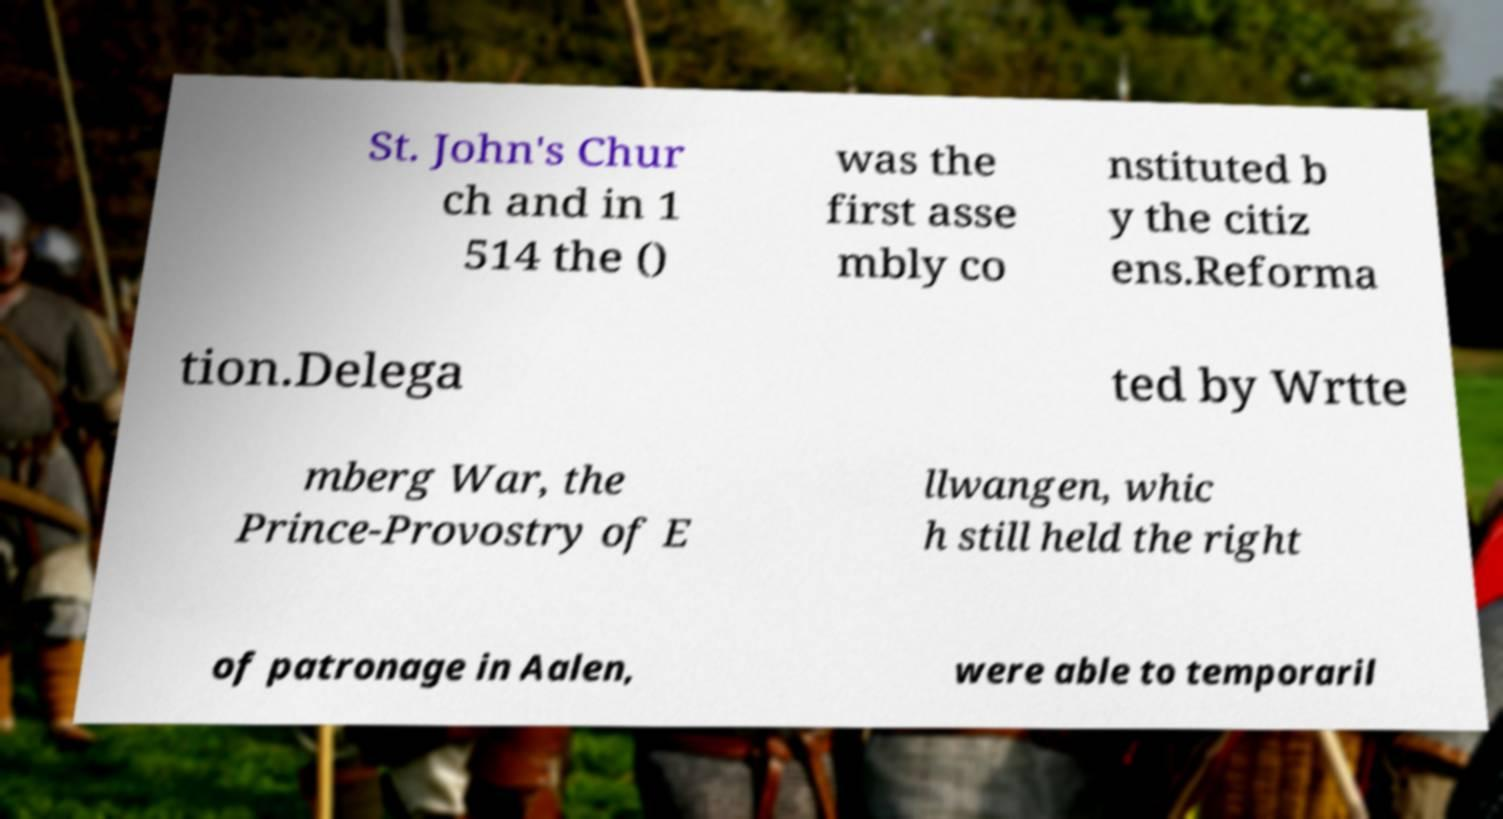Can you accurately transcribe the text from the provided image for me? St. John's Chur ch and in 1 514 the () was the first asse mbly co nstituted b y the citiz ens.Reforma tion.Delega ted by Wrtte mberg War, the Prince-Provostry of E llwangen, whic h still held the right of patronage in Aalen, were able to temporaril 